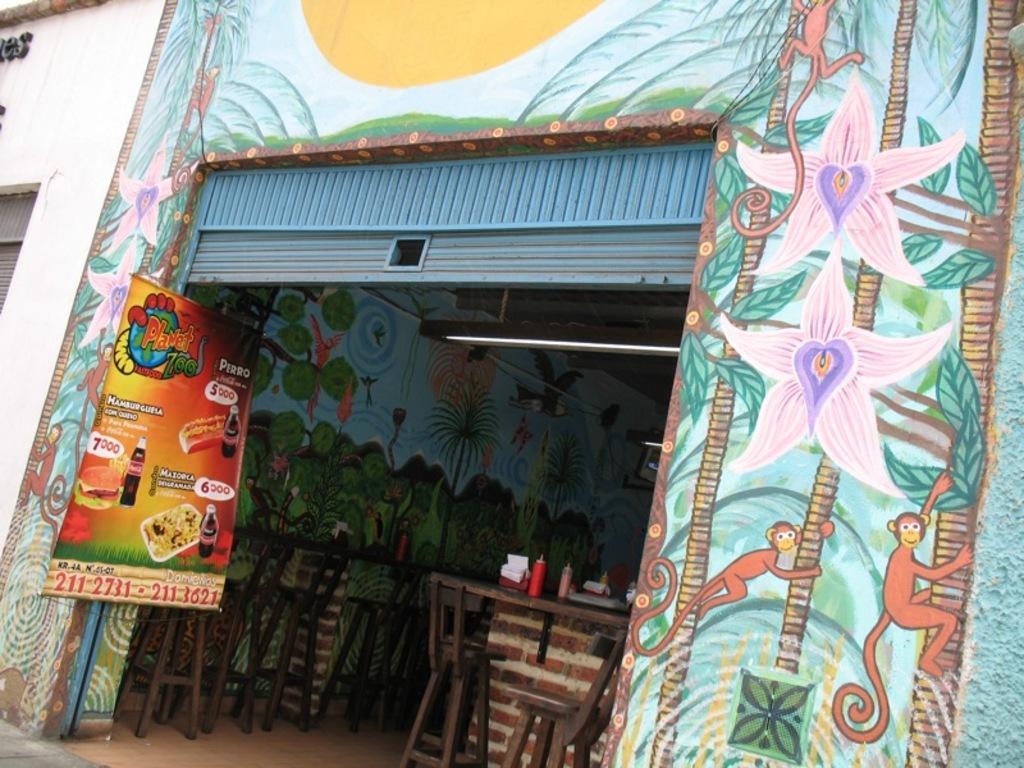How would you summarize this image in a sentence or two? In this image we can see a building with a stall and it looks like a restaurant and we can see the walls with painting. There are some tables and chairs and there are some objects on the table. 